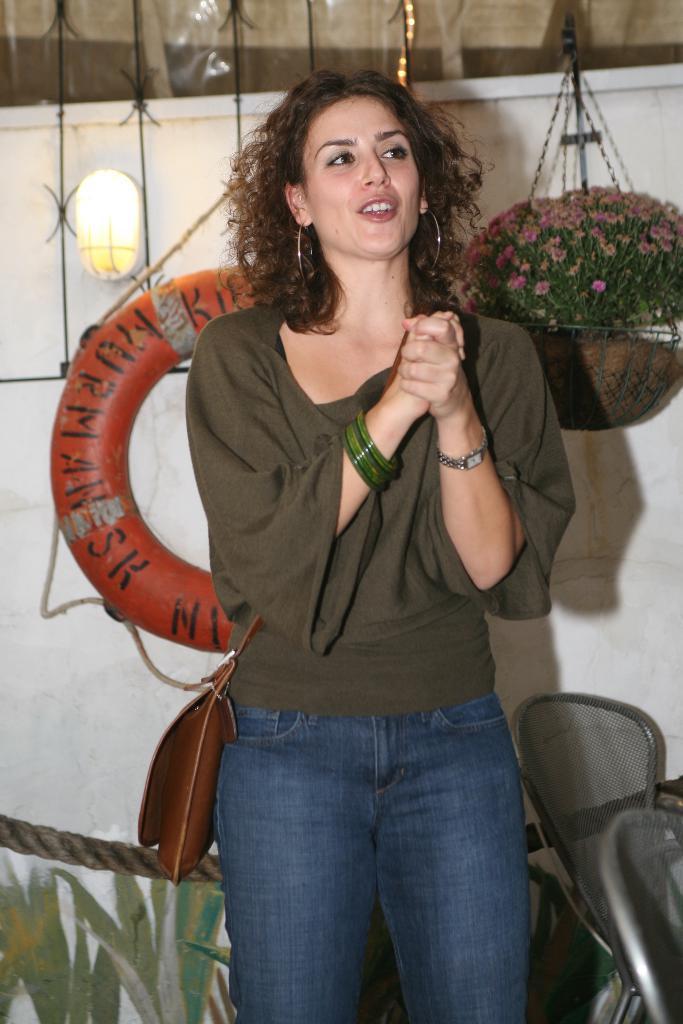Please provide a concise description of this image. In this picture we can see a woman standing and looking at someone. In the background, we can see a tube, a light & a hanging flower pot. 